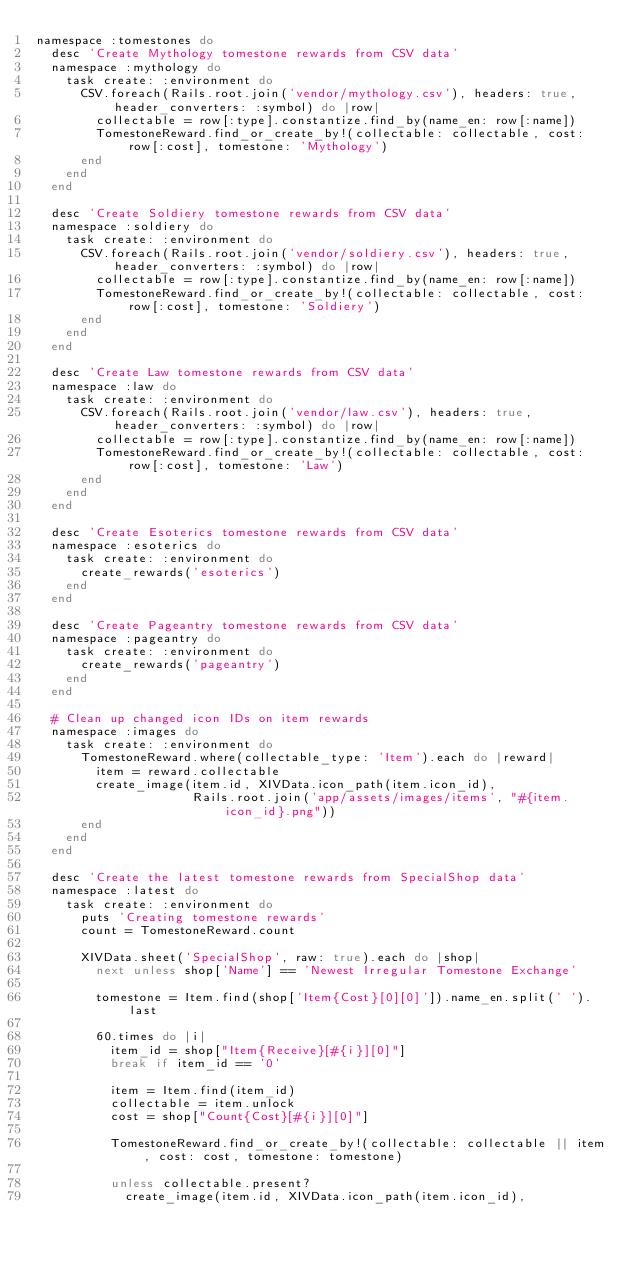Convert code to text. <code><loc_0><loc_0><loc_500><loc_500><_Ruby_>namespace :tomestones do
  desc 'Create Mythology tomestone rewards from CSV data'
  namespace :mythology do
    task create: :environment do
      CSV.foreach(Rails.root.join('vendor/mythology.csv'), headers: true, header_converters: :symbol) do |row|
        collectable = row[:type].constantize.find_by(name_en: row[:name])
        TomestoneReward.find_or_create_by!(collectable: collectable, cost: row[:cost], tomestone: 'Mythology')
      end
    end
  end

  desc 'Create Soldiery tomestone rewards from CSV data'
  namespace :soldiery do
    task create: :environment do
      CSV.foreach(Rails.root.join('vendor/soldiery.csv'), headers: true, header_converters: :symbol) do |row|
        collectable = row[:type].constantize.find_by(name_en: row[:name])
        TomestoneReward.find_or_create_by!(collectable: collectable, cost: row[:cost], tomestone: 'Soldiery')
      end
    end
  end

  desc 'Create Law tomestone rewards from CSV data'
  namespace :law do
    task create: :environment do
      CSV.foreach(Rails.root.join('vendor/law.csv'), headers: true, header_converters: :symbol) do |row|
        collectable = row[:type].constantize.find_by(name_en: row[:name])
        TomestoneReward.find_or_create_by!(collectable: collectable, cost: row[:cost], tomestone: 'Law')
      end
    end
  end

  desc 'Create Esoterics tomestone rewards from CSV data'
  namespace :esoterics do
    task create: :environment do
      create_rewards('esoterics')
    end
  end

  desc 'Create Pageantry tomestone rewards from CSV data'
  namespace :pageantry do
    task create: :environment do
      create_rewards('pageantry')
    end
  end

  # Clean up changed icon IDs on item rewards
  namespace :images do
    task create: :environment do
      TomestoneReward.where(collectable_type: 'Item').each do |reward|
        item = reward.collectable
        create_image(item.id, XIVData.icon_path(item.icon_id),
                     Rails.root.join('app/assets/images/items', "#{item.icon_id}.png"))
      end
    end
  end

  desc 'Create the latest tomestone rewards from SpecialShop data'
  namespace :latest do
    task create: :environment do
      puts 'Creating tomestone rewards'
      count = TomestoneReward.count

      XIVData.sheet('SpecialShop', raw: true).each do |shop|
        next unless shop['Name'] == 'Newest Irregular Tomestone Exchange'

        tomestone = Item.find(shop['Item{Cost}[0][0]']).name_en.split(' ').last

        60.times do |i|
          item_id = shop["Item{Receive}[#{i}][0]"]
          break if item_id == '0'

          item = Item.find(item_id)
          collectable = item.unlock
          cost = shop["Count{Cost}[#{i}][0]"]

          TomestoneReward.find_or_create_by!(collectable: collectable || item, cost: cost, tomestone: tomestone)

          unless collectable.present?
            create_image(item.id, XIVData.icon_path(item.icon_id),</code> 